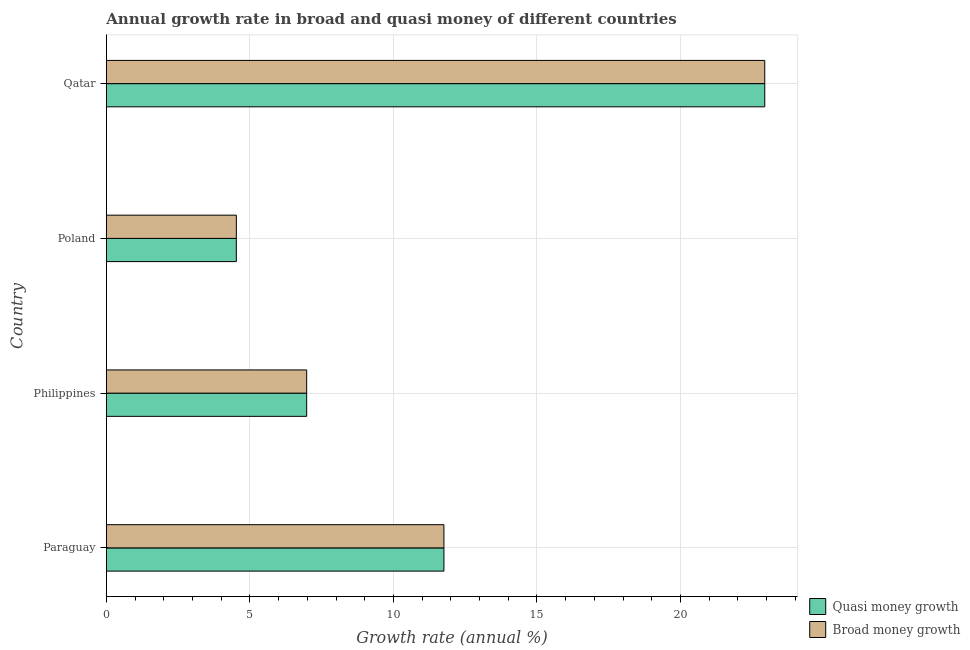How many different coloured bars are there?
Offer a terse response. 2. Are the number of bars per tick equal to the number of legend labels?
Provide a succinct answer. Yes. Are the number of bars on each tick of the Y-axis equal?
Ensure brevity in your answer.  Yes. In how many cases, is the number of bars for a given country not equal to the number of legend labels?
Provide a short and direct response. 0. What is the annual growth rate in quasi money in Qatar?
Your answer should be very brief. 22.93. Across all countries, what is the maximum annual growth rate in quasi money?
Give a very brief answer. 22.93. Across all countries, what is the minimum annual growth rate in broad money?
Offer a terse response. 4.53. In which country was the annual growth rate in broad money maximum?
Your response must be concise. Qatar. In which country was the annual growth rate in broad money minimum?
Your answer should be compact. Poland. What is the total annual growth rate in quasi money in the graph?
Your response must be concise. 46.2. What is the difference between the annual growth rate in quasi money in Philippines and that in Qatar?
Your answer should be compact. -15.96. What is the difference between the annual growth rate in quasi money in Philippines and the annual growth rate in broad money in Poland?
Your response must be concise. 2.45. What is the average annual growth rate in broad money per country?
Offer a very short reply. 11.55. What is the difference between the annual growth rate in broad money and annual growth rate in quasi money in Philippines?
Provide a succinct answer. 0. What is the ratio of the annual growth rate in quasi money in Poland to that in Qatar?
Give a very brief answer. 0.2. Is the difference between the annual growth rate in broad money in Philippines and Poland greater than the difference between the annual growth rate in quasi money in Philippines and Poland?
Your answer should be very brief. No. What is the difference between the highest and the second highest annual growth rate in broad money?
Keep it short and to the point. 11.18. What is the difference between the highest and the lowest annual growth rate in quasi money?
Ensure brevity in your answer.  18.41. Is the sum of the annual growth rate in broad money in Paraguay and Qatar greater than the maximum annual growth rate in quasi money across all countries?
Offer a terse response. Yes. What does the 2nd bar from the top in Paraguay represents?
Make the answer very short. Quasi money growth. What does the 2nd bar from the bottom in Qatar represents?
Your response must be concise. Broad money growth. How many bars are there?
Give a very brief answer. 8. Are the values on the major ticks of X-axis written in scientific E-notation?
Offer a very short reply. No. How many legend labels are there?
Ensure brevity in your answer.  2. How are the legend labels stacked?
Your answer should be compact. Vertical. What is the title of the graph?
Your answer should be very brief. Annual growth rate in broad and quasi money of different countries. Does "Infant" appear as one of the legend labels in the graph?
Your response must be concise. No. What is the label or title of the X-axis?
Your answer should be compact. Growth rate (annual %). What is the Growth rate (annual %) in Quasi money growth in Paraguay?
Your response must be concise. 11.76. What is the Growth rate (annual %) of Broad money growth in Paraguay?
Provide a succinct answer. 11.76. What is the Growth rate (annual %) in Quasi money growth in Philippines?
Provide a succinct answer. 6.98. What is the Growth rate (annual %) of Broad money growth in Philippines?
Ensure brevity in your answer.  6.98. What is the Growth rate (annual %) in Quasi money growth in Poland?
Offer a terse response. 4.53. What is the Growth rate (annual %) of Broad money growth in Poland?
Offer a very short reply. 4.53. What is the Growth rate (annual %) of Quasi money growth in Qatar?
Your response must be concise. 22.93. What is the Growth rate (annual %) in Broad money growth in Qatar?
Your answer should be very brief. 22.93. Across all countries, what is the maximum Growth rate (annual %) in Quasi money growth?
Your answer should be very brief. 22.93. Across all countries, what is the maximum Growth rate (annual %) of Broad money growth?
Your answer should be compact. 22.93. Across all countries, what is the minimum Growth rate (annual %) in Quasi money growth?
Keep it short and to the point. 4.53. Across all countries, what is the minimum Growth rate (annual %) of Broad money growth?
Your answer should be very brief. 4.53. What is the total Growth rate (annual %) of Quasi money growth in the graph?
Your response must be concise. 46.2. What is the total Growth rate (annual %) of Broad money growth in the graph?
Your answer should be very brief. 46.2. What is the difference between the Growth rate (annual %) of Quasi money growth in Paraguay and that in Philippines?
Your answer should be compact. 4.78. What is the difference between the Growth rate (annual %) of Broad money growth in Paraguay and that in Philippines?
Keep it short and to the point. 4.78. What is the difference between the Growth rate (annual %) of Quasi money growth in Paraguay and that in Poland?
Your answer should be compact. 7.23. What is the difference between the Growth rate (annual %) in Broad money growth in Paraguay and that in Poland?
Your answer should be very brief. 7.23. What is the difference between the Growth rate (annual %) of Quasi money growth in Paraguay and that in Qatar?
Make the answer very short. -11.18. What is the difference between the Growth rate (annual %) in Broad money growth in Paraguay and that in Qatar?
Your response must be concise. -11.18. What is the difference between the Growth rate (annual %) in Quasi money growth in Philippines and that in Poland?
Provide a succinct answer. 2.45. What is the difference between the Growth rate (annual %) in Broad money growth in Philippines and that in Poland?
Offer a terse response. 2.45. What is the difference between the Growth rate (annual %) of Quasi money growth in Philippines and that in Qatar?
Keep it short and to the point. -15.96. What is the difference between the Growth rate (annual %) of Broad money growth in Philippines and that in Qatar?
Ensure brevity in your answer.  -15.96. What is the difference between the Growth rate (annual %) of Quasi money growth in Poland and that in Qatar?
Ensure brevity in your answer.  -18.41. What is the difference between the Growth rate (annual %) in Broad money growth in Poland and that in Qatar?
Provide a short and direct response. -18.41. What is the difference between the Growth rate (annual %) in Quasi money growth in Paraguay and the Growth rate (annual %) in Broad money growth in Philippines?
Your answer should be compact. 4.78. What is the difference between the Growth rate (annual %) in Quasi money growth in Paraguay and the Growth rate (annual %) in Broad money growth in Poland?
Ensure brevity in your answer.  7.23. What is the difference between the Growth rate (annual %) of Quasi money growth in Paraguay and the Growth rate (annual %) of Broad money growth in Qatar?
Your answer should be very brief. -11.18. What is the difference between the Growth rate (annual %) of Quasi money growth in Philippines and the Growth rate (annual %) of Broad money growth in Poland?
Give a very brief answer. 2.45. What is the difference between the Growth rate (annual %) of Quasi money growth in Philippines and the Growth rate (annual %) of Broad money growth in Qatar?
Keep it short and to the point. -15.96. What is the difference between the Growth rate (annual %) in Quasi money growth in Poland and the Growth rate (annual %) in Broad money growth in Qatar?
Keep it short and to the point. -18.41. What is the average Growth rate (annual %) of Quasi money growth per country?
Give a very brief answer. 11.55. What is the average Growth rate (annual %) in Broad money growth per country?
Provide a succinct answer. 11.55. What is the difference between the Growth rate (annual %) in Quasi money growth and Growth rate (annual %) in Broad money growth in Paraguay?
Offer a very short reply. 0. What is the difference between the Growth rate (annual %) of Quasi money growth and Growth rate (annual %) of Broad money growth in Poland?
Provide a short and direct response. 0. What is the difference between the Growth rate (annual %) of Quasi money growth and Growth rate (annual %) of Broad money growth in Qatar?
Your answer should be very brief. 0. What is the ratio of the Growth rate (annual %) of Quasi money growth in Paraguay to that in Philippines?
Your answer should be compact. 1.69. What is the ratio of the Growth rate (annual %) in Broad money growth in Paraguay to that in Philippines?
Your response must be concise. 1.69. What is the ratio of the Growth rate (annual %) of Quasi money growth in Paraguay to that in Poland?
Your answer should be compact. 2.6. What is the ratio of the Growth rate (annual %) in Broad money growth in Paraguay to that in Poland?
Your answer should be very brief. 2.6. What is the ratio of the Growth rate (annual %) of Quasi money growth in Paraguay to that in Qatar?
Make the answer very short. 0.51. What is the ratio of the Growth rate (annual %) in Broad money growth in Paraguay to that in Qatar?
Ensure brevity in your answer.  0.51. What is the ratio of the Growth rate (annual %) in Quasi money growth in Philippines to that in Poland?
Your answer should be compact. 1.54. What is the ratio of the Growth rate (annual %) in Broad money growth in Philippines to that in Poland?
Provide a succinct answer. 1.54. What is the ratio of the Growth rate (annual %) in Quasi money growth in Philippines to that in Qatar?
Offer a terse response. 0.3. What is the ratio of the Growth rate (annual %) of Broad money growth in Philippines to that in Qatar?
Ensure brevity in your answer.  0.3. What is the ratio of the Growth rate (annual %) in Quasi money growth in Poland to that in Qatar?
Provide a short and direct response. 0.2. What is the ratio of the Growth rate (annual %) of Broad money growth in Poland to that in Qatar?
Provide a short and direct response. 0.2. What is the difference between the highest and the second highest Growth rate (annual %) in Quasi money growth?
Offer a terse response. 11.18. What is the difference between the highest and the second highest Growth rate (annual %) in Broad money growth?
Make the answer very short. 11.18. What is the difference between the highest and the lowest Growth rate (annual %) in Quasi money growth?
Ensure brevity in your answer.  18.41. What is the difference between the highest and the lowest Growth rate (annual %) in Broad money growth?
Make the answer very short. 18.41. 